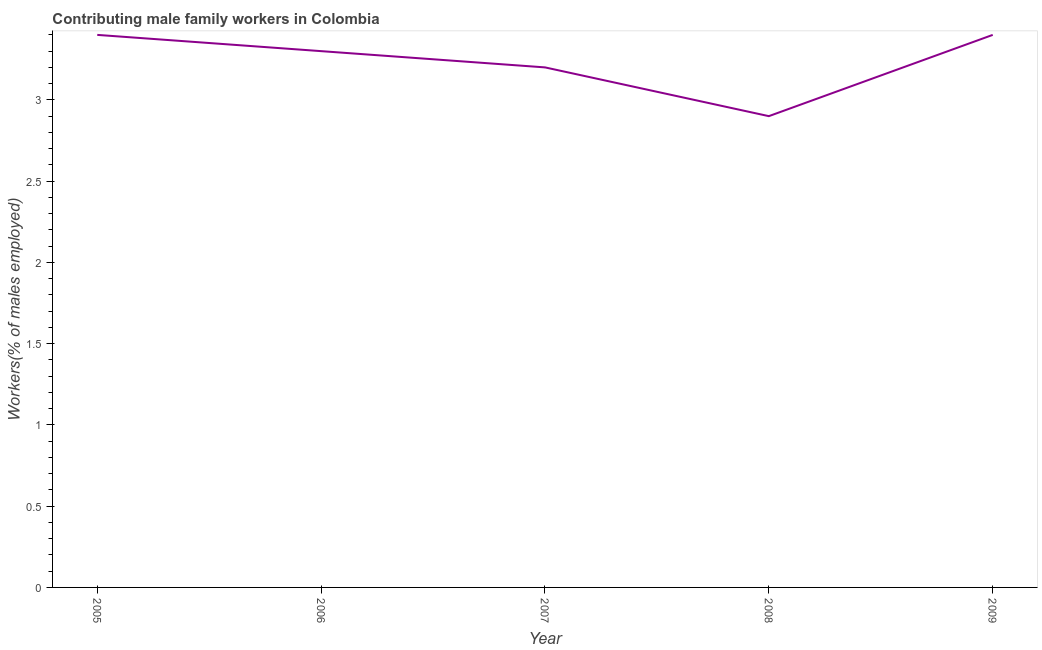What is the contributing male family workers in 2008?
Provide a short and direct response. 2.9. Across all years, what is the maximum contributing male family workers?
Provide a succinct answer. 3.4. Across all years, what is the minimum contributing male family workers?
Your response must be concise. 2.9. In which year was the contributing male family workers maximum?
Your answer should be very brief. 2005. What is the sum of the contributing male family workers?
Keep it short and to the point. 16.2. What is the average contributing male family workers per year?
Your answer should be very brief. 3.24. What is the median contributing male family workers?
Offer a terse response. 3.3. Do a majority of the years between 2005 and 2008 (inclusive) have contributing male family workers greater than 3.2 %?
Provide a succinct answer. Yes. What is the ratio of the contributing male family workers in 2006 to that in 2008?
Keep it short and to the point. 1.14. Is the contributing male family workers in 2005 less than that in 2006?
Ensure brevity in your answer.  No. Is the difference between the contributing male family workers in 2007 and 2009 greater than the difference between any two years?
Make the answer very short. No. Is the sum of the contributing male family workers in 2005 and 2009 greater than the maximum contributing male family workers across all years?
Provide a short and direct response. Yes. In how many years, is the contributing male family workers greater than the average contributing male family workers taken over all years?
Provide a succinct answer. 3. Does the contributing male family workers monotonically increase over the years?
Keep it short and to the point. No. Does the graph contain any zero values?
Keep it short and to the point. No. What is the title of the graph?
Offer a very short reply. Contributing male family workers in Colombia. What is the label or title of the X-axis?
Provide a short and direct response. Year. What is the label or title of the Y-axis?
Provide a succinct answer. Workers(% of males employed). What is the Workers(% of males employed) in 2005?
Your answer should be compact. 3.4. What is the Workers(% of males employed) of 2006?
Provide a short and direct response. 3.3. What is the Workers(% of males employed) in 2007?
Provide a succinct answer. 3.2. What is the Workers(% of males employed) of 2008?
Your answer should be compact. 2.9. What is the Workers(% of males employed) in 2009?
Offer a very short reply. 3.4. What is the difference between the Workers(% of males employed) in 2005 and 2009?
Offer a terse response. 0. What is the difference between the Workers(% of males employed) in 2007 and 2008?
Make the answer very short. 0.3. What is the difference between the Workers(% of males employed) in 2008 and 2009?
Ensure brevity in your answer.  -0.5. What is the ratio of the Workers(% of males employed) in 2005 to that in 2007?
Ensure brevity in your answer.  1.06. What is the ratio of the Workers(% of males employed) in 2005 to that in 2008?
Your answer should be very brief. 1.17. What is the ratio of the Workers(% of males employed) in 2005 to that in 2009?
Provide a short and direct response. 1. What is the ratio of the Workers(% of males employed) in 2006 to that in 2007?
Offer a terse response. 1.03. What is the ratio of the Workers(% of males employed) in 2006 to that in 2008?
Offer a terse response. 1.14. What is the ratio of the Workers(% of males employed) in 2007 to that in 2008?
Your response must be concise. 1.1. What is the ratio of the Workers(% of males employed) in 2007 to that in 2009?
Offer a terse response. 0.94. What is the ratio of the Workers(% of males employed) in 2008 to that in 2009?
Provide a succinct answer. 0.85. 